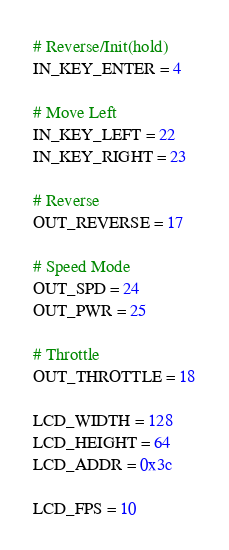<code> <loc_0><loc_0><loc_500><loc_500><_Python_># Reverse/Init(hold)
IN_KEY_ENTER = 4

# Move Left
IN_KEY_LEFT = 22
IN_KEY_RIGHT = 23

# Reverse
OUT_REVERSE = 17

# Speed Mode
OUT_SPD = 24
OUT_PWR = 25

# Throttle
OUT_THROTTLE = 18

LCD_WIDTH = 128
LCD_HEIGHT = 64
LCD_ADDR = 0x3c

LCD_FPS = 10
</code> 